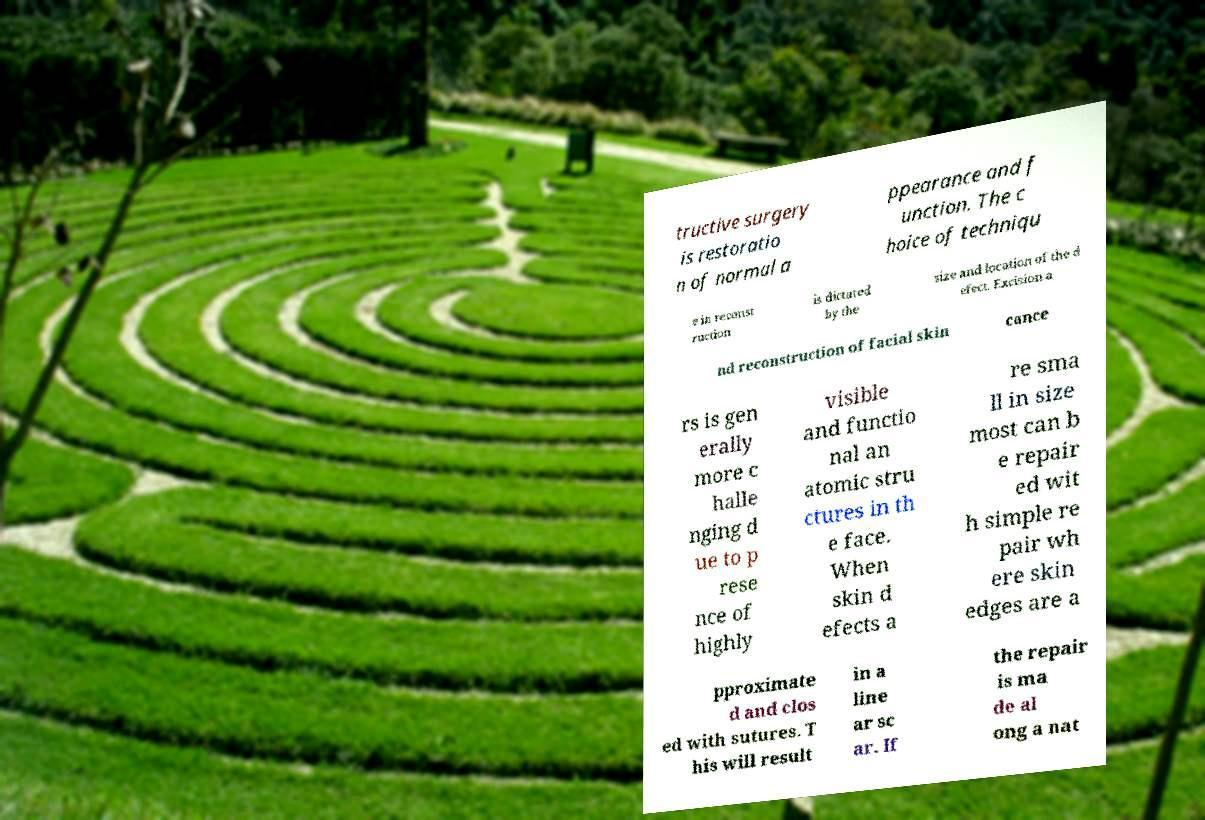There's text embedded in this image that I need extracted. Can you transcribe it verbatim? tructive surgery is restoratio n of normal a ppearance and f unction. The c hoice of techniqu e in reconst ruction is dictated by the size and location of the d efect. Excision a nd reconstruction of facial skin cance rs is gen erally more c halle nging d ue to p rese nce of highly visible and functio nal an atomic stru ctures in th e face. When skin d efects a re sma ll in size most can b e repair ed wit h simple re pair wh ere skin edges are a pproximate d and clos ed with sutures. T his will result in a line ar sc ar. If the repair is ma de al ong a nat 